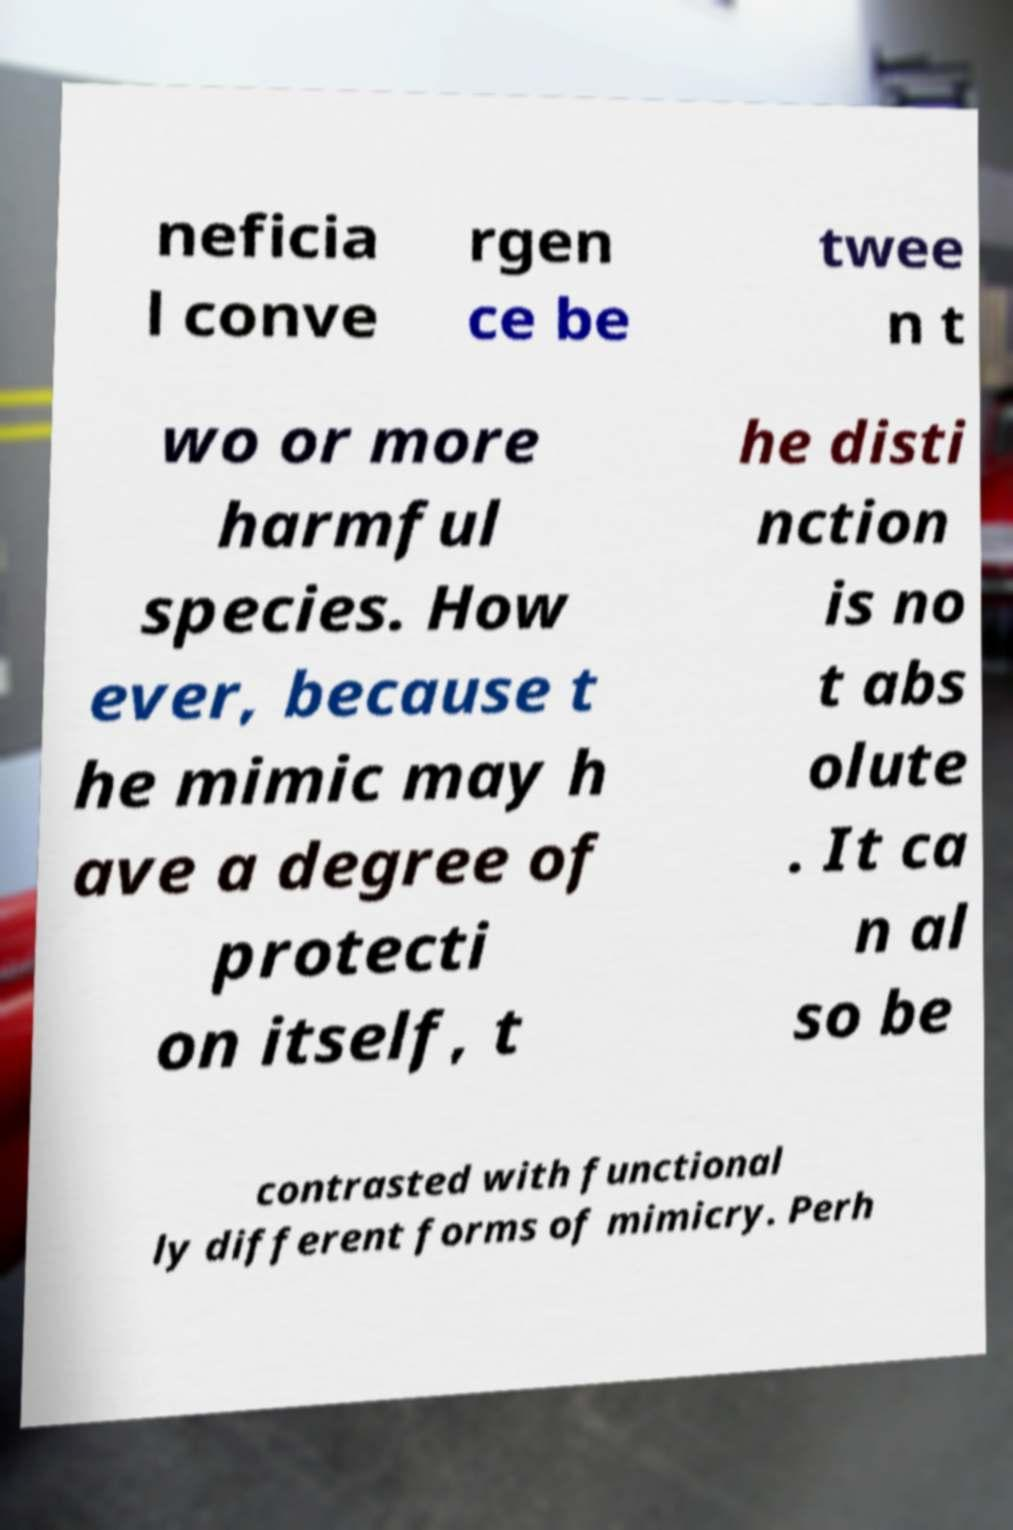There's text embedded in this image that I need extracted. Can you transcribe it verbatim? neficia l conve rgen ce be twee n t wo or more harmful species. How ever, because t he mimic may h ave a degree of protecti on itself, t he disti nction is no t abs olute . It ca n al so be contrasted with functional ly different forms of mimicry. Perh 